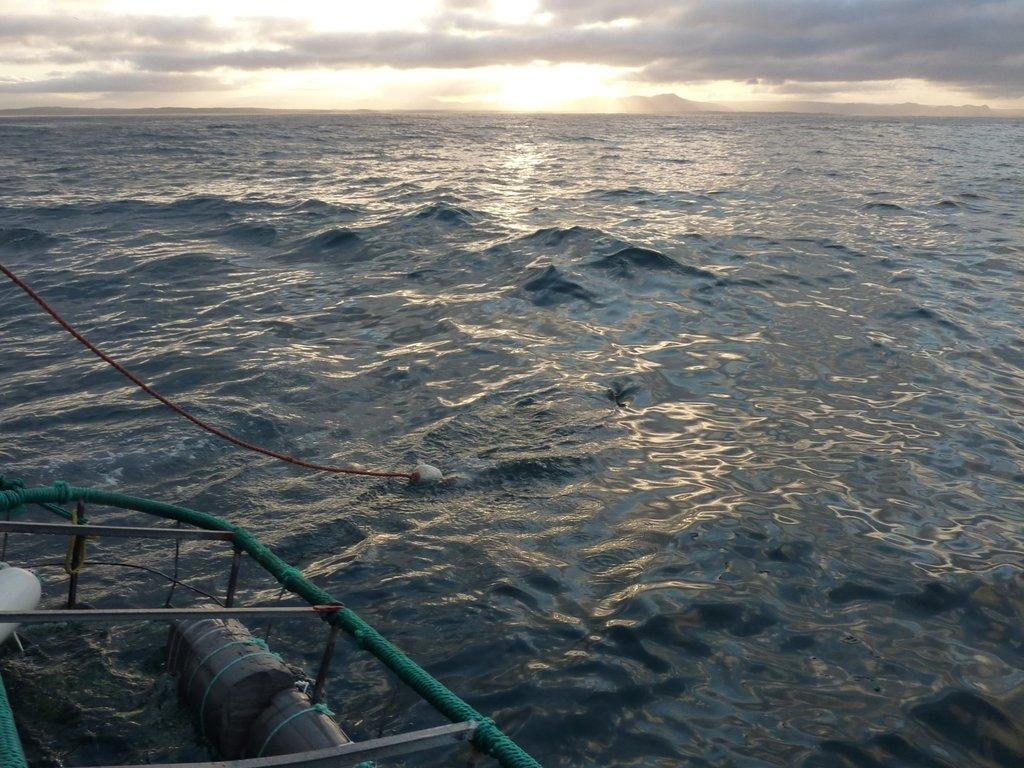What is the main element present in the image? There is water in the image. What can be seen on the left side of the image? There is a boat on the left side of the image. What object is visible in the image that might be used for tying or pulling? There is a rope visible in the image. What is visible at the top of the image? The sky is visible at the top of the image. How many giraffes can be seen in the image? There are no giraffes present in the image. What type of boats are visible in the image? The image only shows one boat, so we cannot determine the type of boats from the information provided. 